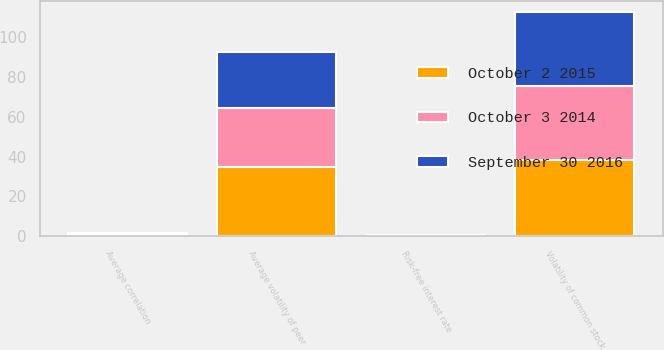Convert chart. <chart><loc_0><loc_0><loc_500><loc_500><stacked_bar_chart><ecel><fcel>Volatility of common stock<fcel>Average volatility of peer<fcel>Average correlation<fcel>Risk-free interest rate<nl><fcel>October 2 2015<fcel>38.24<fcel>34.76<fcel>0.49<fcel>0.44<nl><fcel>September 30 2016<fcel>37.51<fcel>28.42<fcel>0.55<fcel>0.12<nl><fcel>October 3 2014<fcel>36.96<fcel>29.59<fcel>0.47<fcel>0.11<nl></chart> 